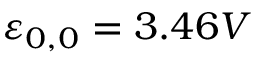Convert formula to latex. <formula><loc_0><loc_0><loc_500><loc_500>\varepsilon _ { 0 , 0 } = 3 . 4 6 V</formula> 